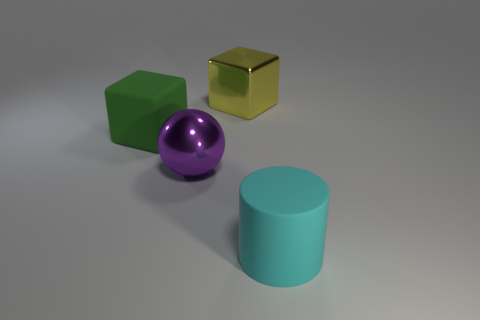Add 2 big shiny objects. How many objects exist? 6 Subtract all cylinders. How many objects are left? 3 Add 2 green cubes. How many green cubes exist? 3 Subtract 0 blue blocks. How many objects are left? 4 Subtract all purple objects. Subtract all small brown matte balls. How many objects are left? 3 Add 2 spheres. How many spheres are left? 3 